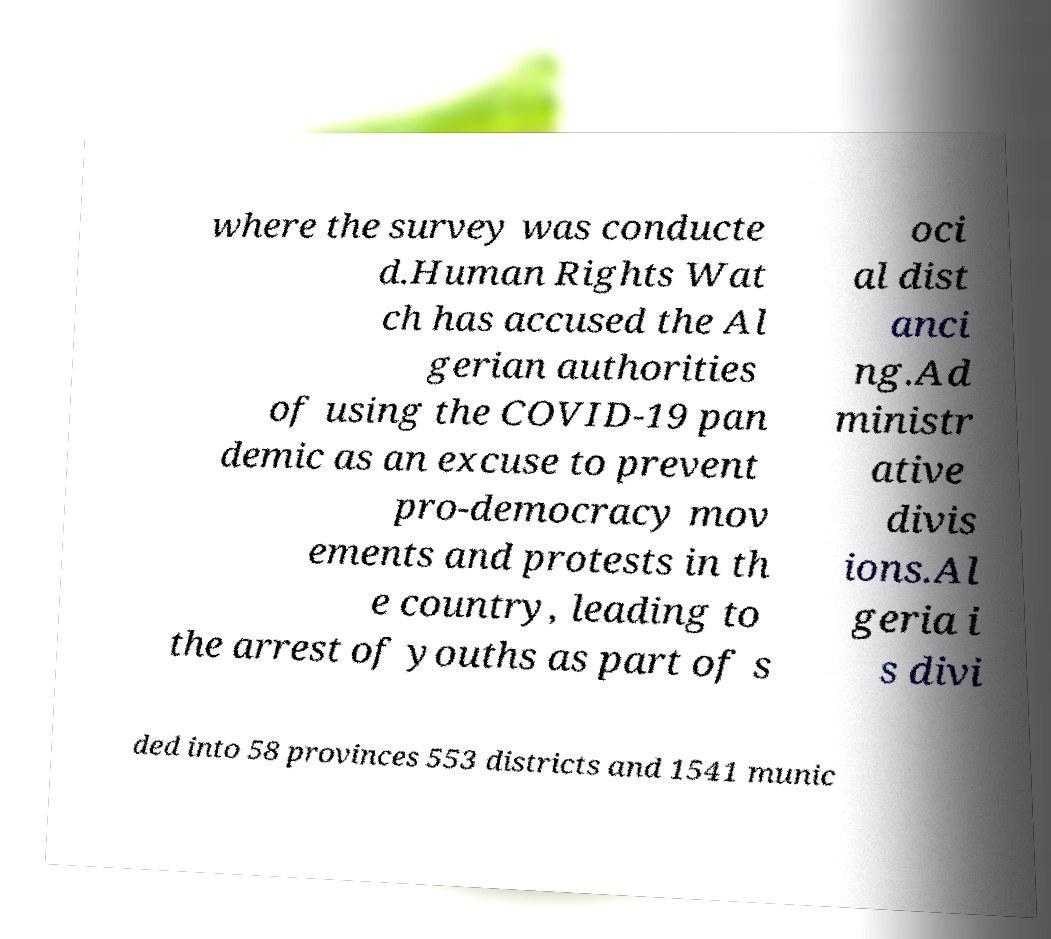Can you accurately transcribe the text from the provided image for me? where the survey was conducte d.Human Rights Wat ch has accused the Al gerian authorities of using the COVID-19 pan demic as an excuse to prevent pro-democracy mov ements and protests in th e country, leading to the arrest of youths as part of s oci al dist anci ng.Ad ministr ative divis ions.Al geria i s divi ded into 58 provinces 553 districts and 1541 munic 